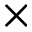Convert formula to latex. <formula><loc_0><loc_0><loc_500><loc_500>\times</formula> 